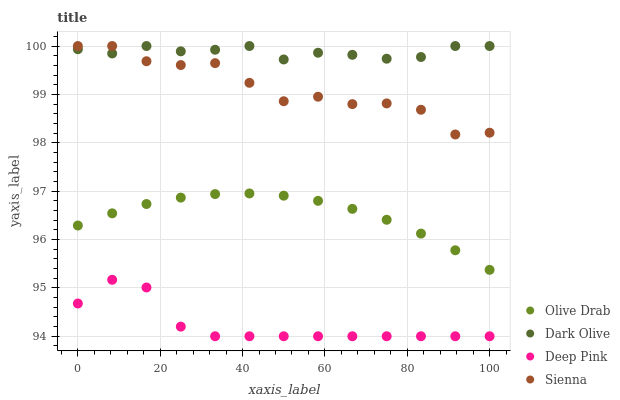Does Deep Pink have the minimum area under the curve?
Answer yes or no. Yes. Does Dark Olive have the maximum area under the curve?
Answer yes or no. Yes. Does Olive Drab have the minimum area under the curve?
Answer yes or no. No. Does Olive Drab have the maximum area under the curve?
Answer yes or no. No. Is Olive Drab the smoothest?
Answer yes or no. Yes. Is Sienna the roughest?
Answer yes or no. Yes. Is Dark Olive the smoothest?
Answer yes or no. No. Is Dark Olive the roughest?
Answer yes or no. No. Does Deep Pink have the lowest value?
Answer yes or no. Yes. Does Olive Drab have the lowest value?
Answer yes or no. No. Does Dark Olive have the highest value?
Answer yes or no. Yes. Does Olive Drab have the highest value?
Answer yes or no. No. Is Deep Pink less than Olive Drab?
Answer yes or no. Yes. Is Dark Olive greater than Olive Drab?
Answer yes or no. Yes. Does Sienna intersect Dark Olive?
Answer yes or no. Yes. Is Sienna less than Dark Olive?
Answer yes or no. No. Is Sienna greater than Dark Olive?
Answer yes or no. No. Does Deep Pink intersect Olive Drab?
Answer yes or no. No. 